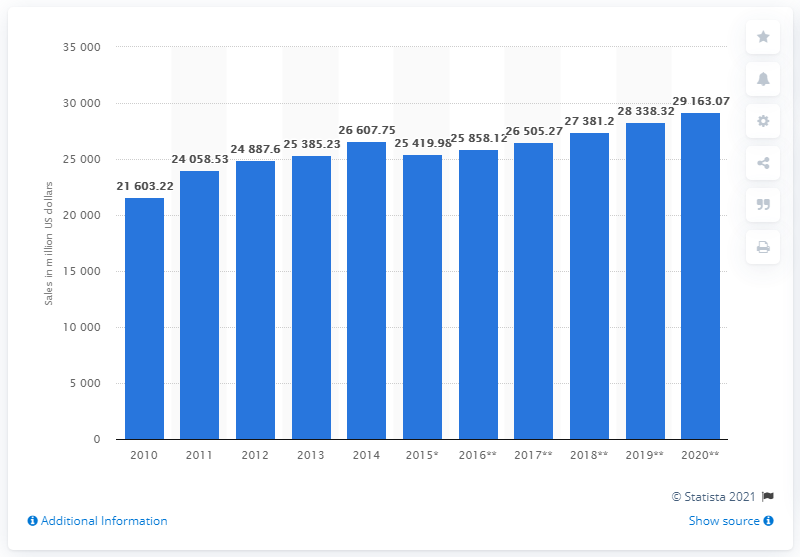Indicate a few pertinent items in this graphic. In 2010, Sainsbury's generated a total of 21,603.22 pounds in sales. The sales forecast for Sainsbury's in the United Kingdom by 2020 is expected to be approximately 29,163.07. 